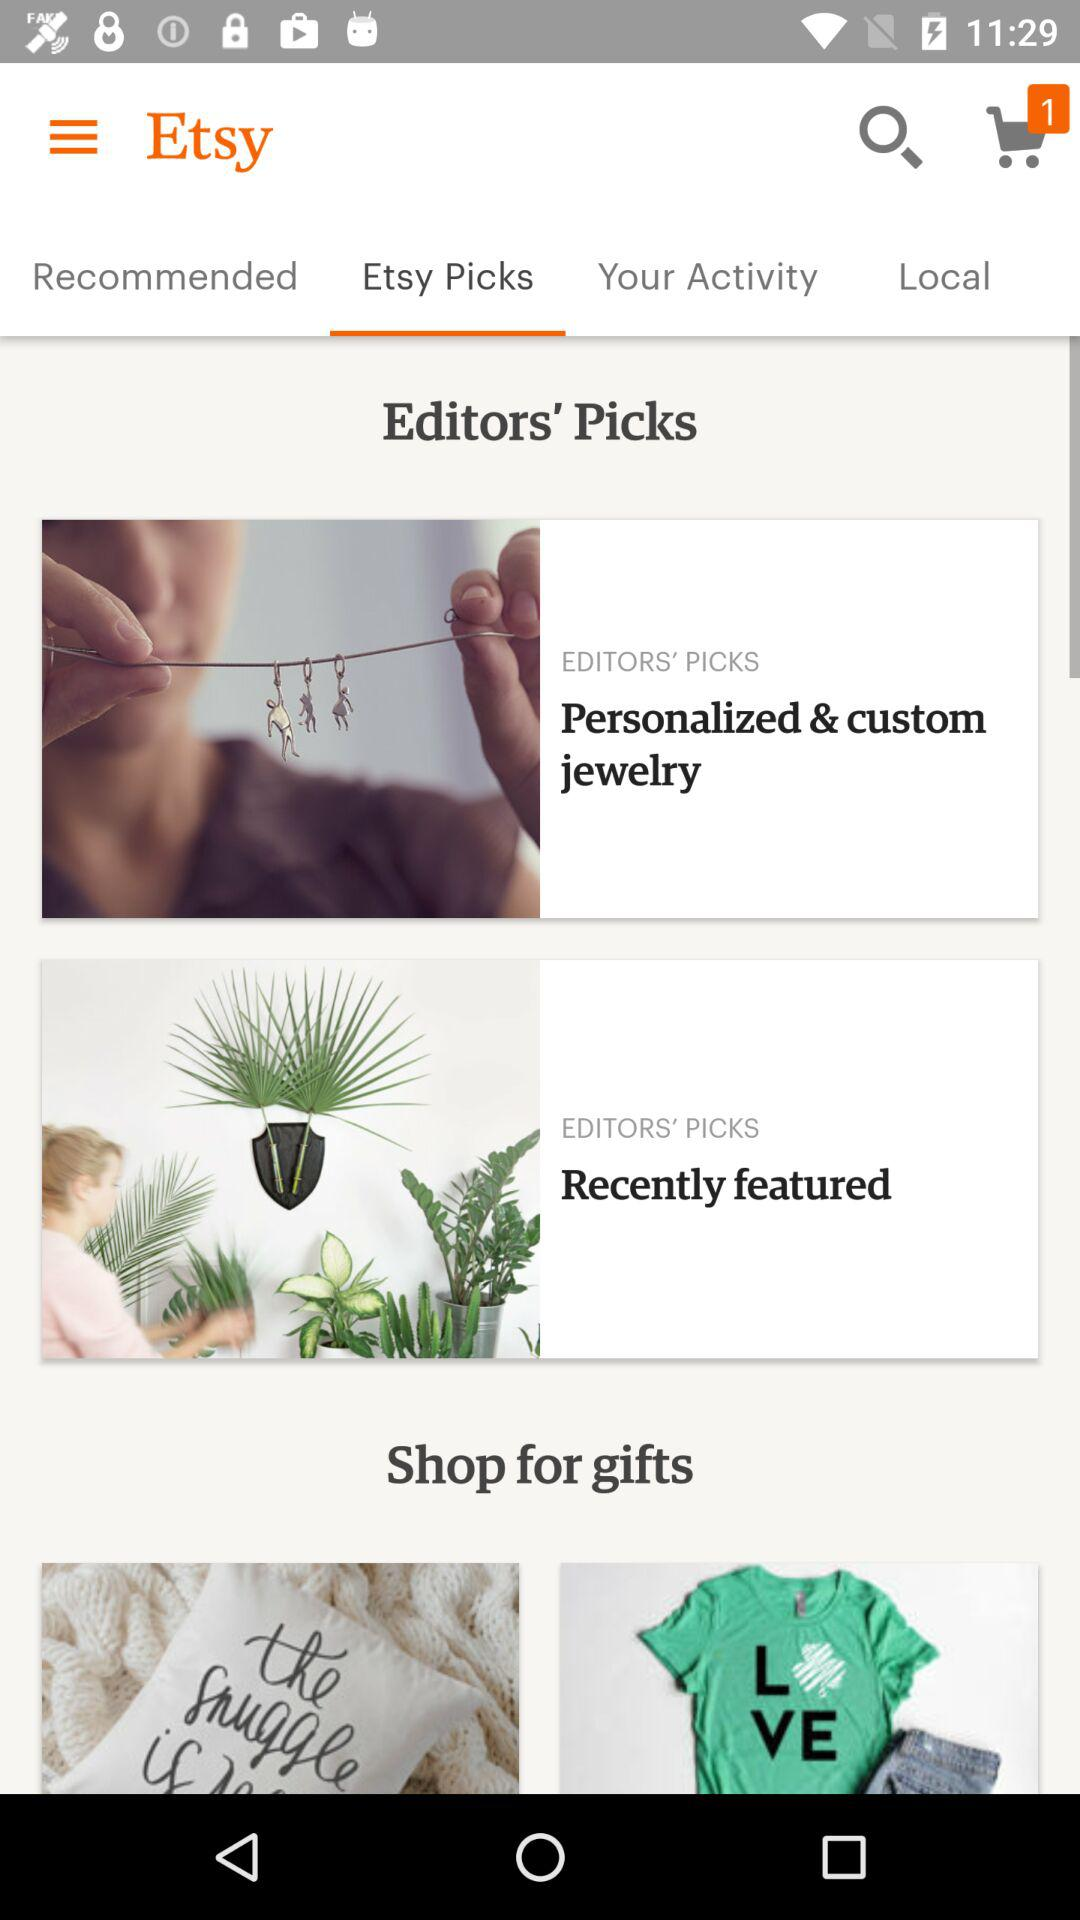Which items are recommended by "Etsy"?
When the provided information is insufficient, respond with <no answer>. <no answer> 